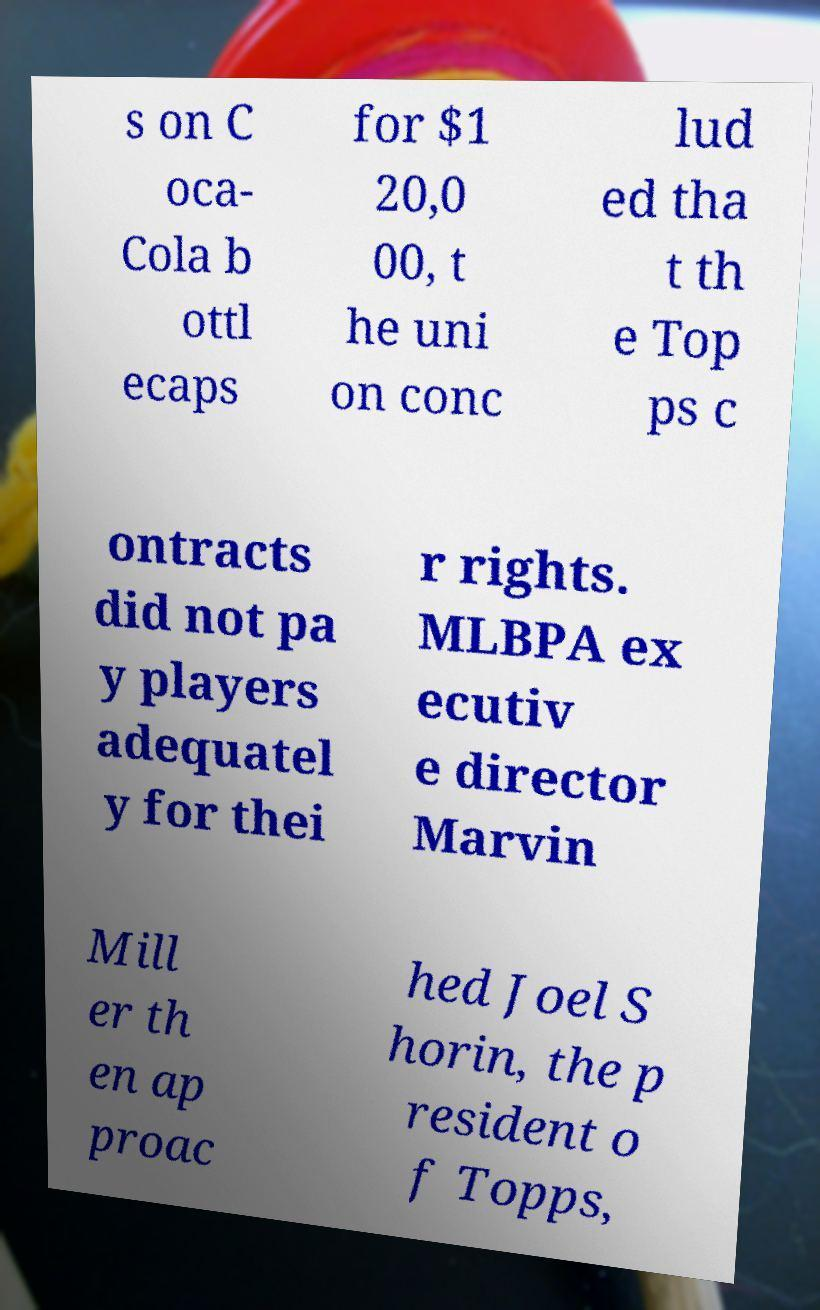Can you read and provide the text displayed in the image?This photo seems to have some interesting text. Can you extract and type it out for me? s on C oca- Cola b ottl ecaps for $1 20,0 00, t he uni on conc lud ed tha t th e Top ps c ontracts did not pa y players adequatel y for thei r rights. MLBPA ex ecutiv e director Marvin Mill er th en ap proac hed Joel S horin, the p resident o f Topps, 